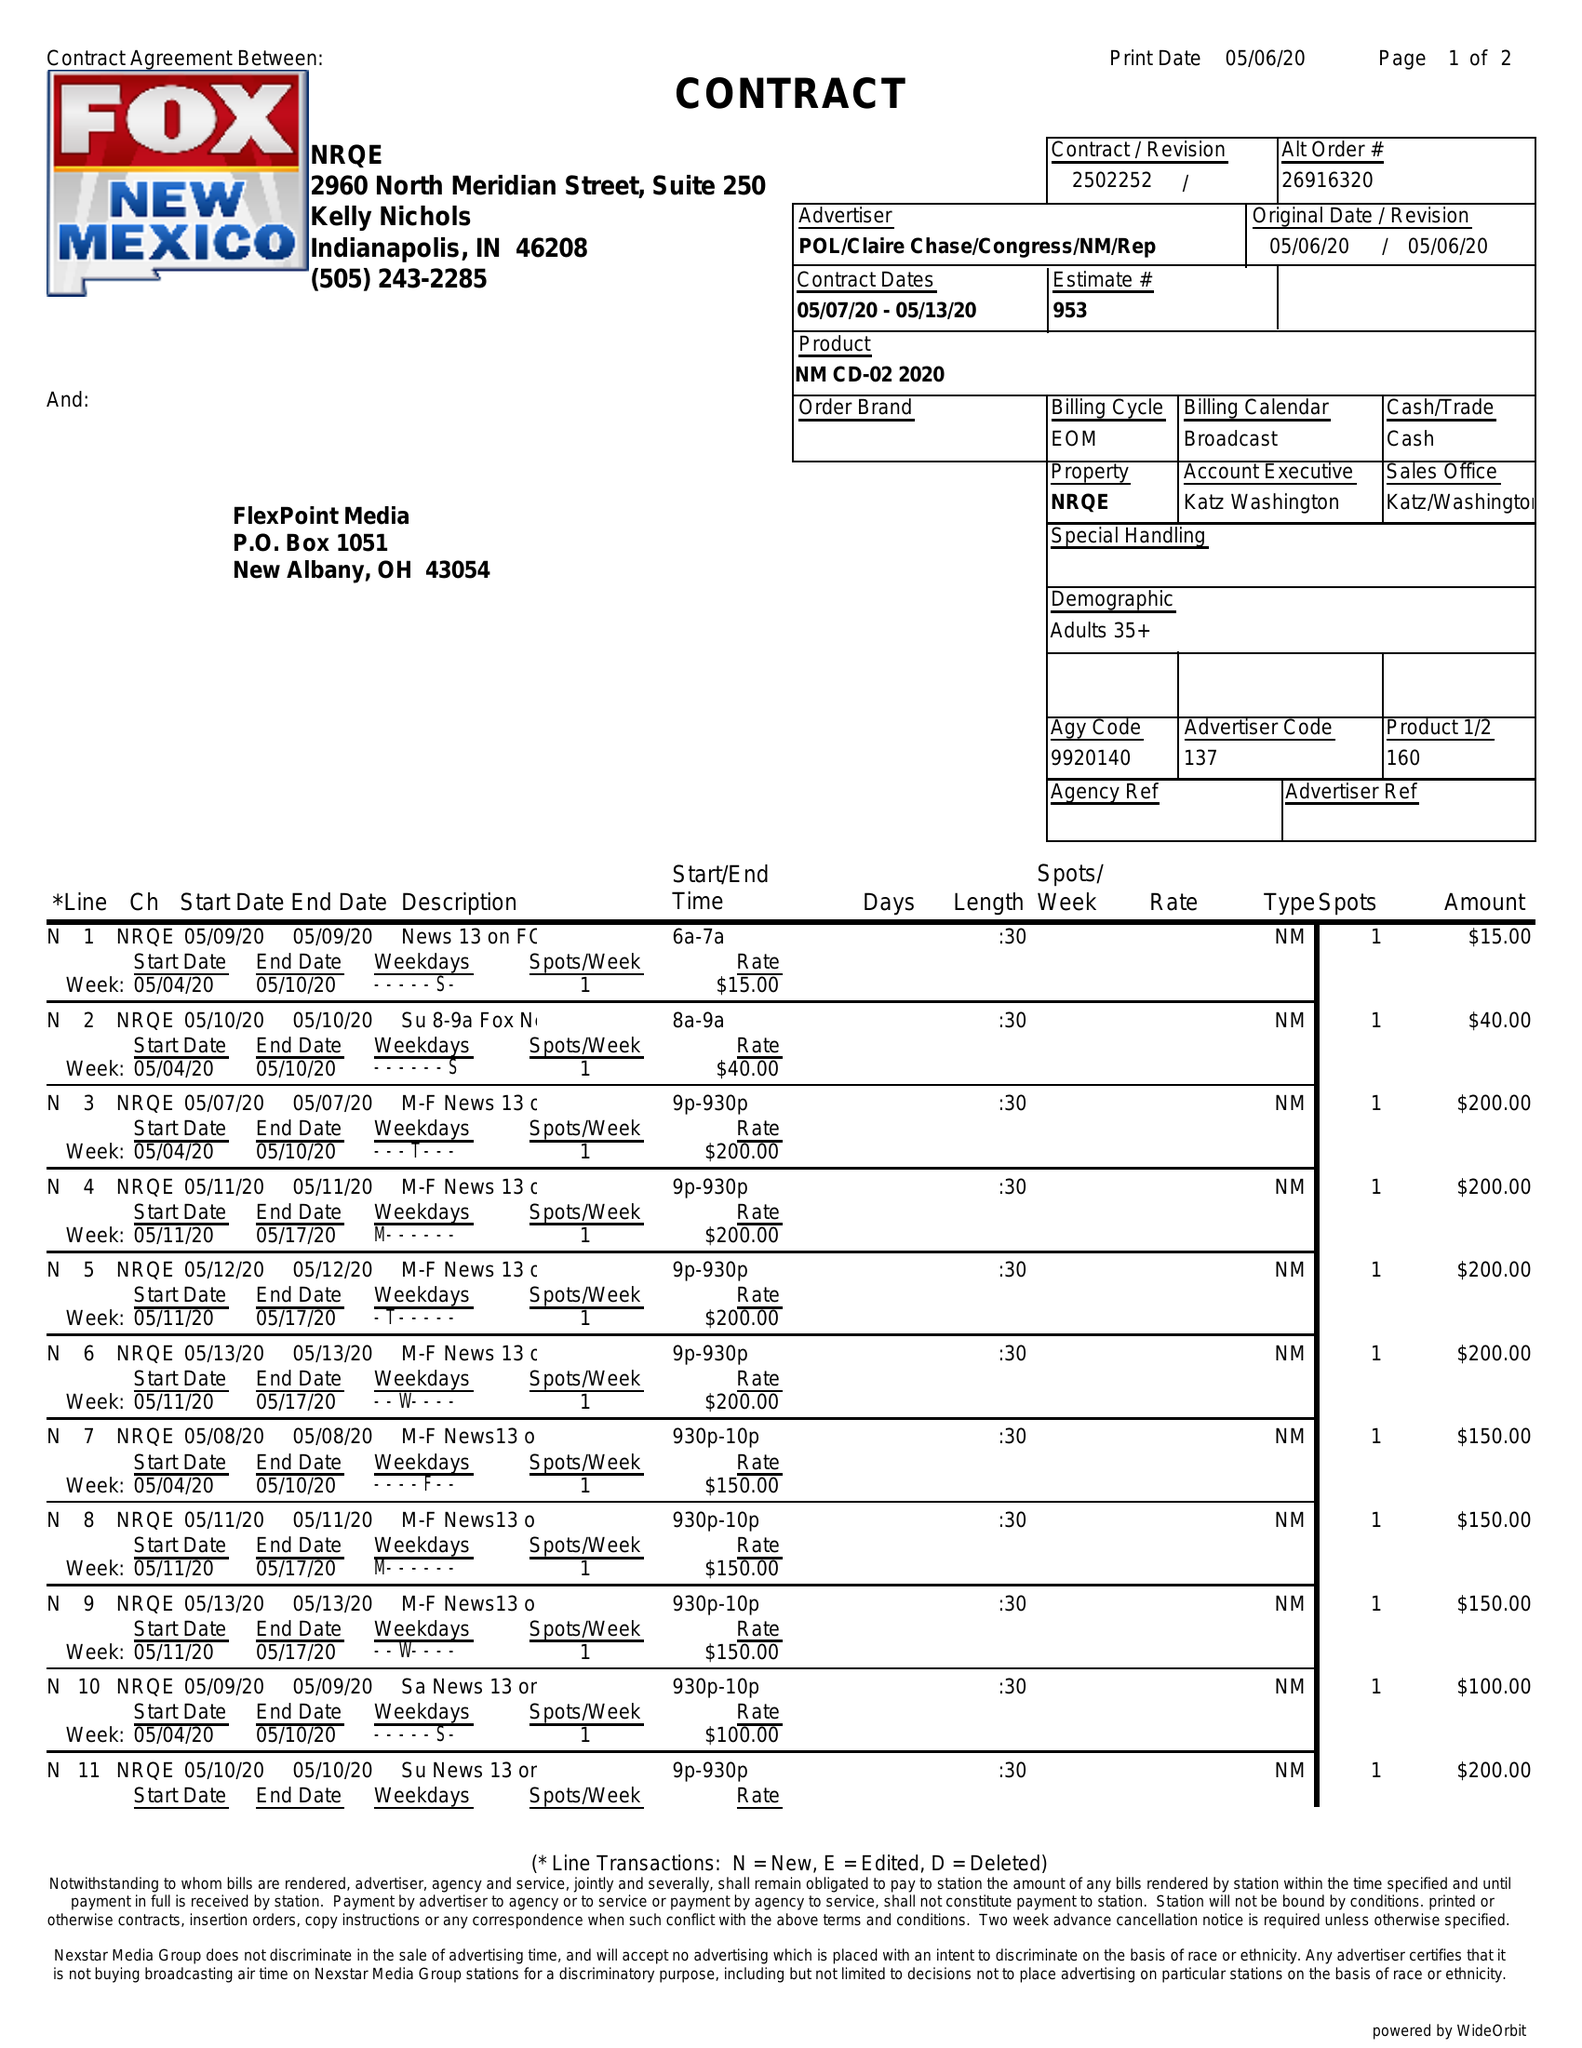What is the value for the contract_num?
Answer the question using a single word or phrase. 2502252 